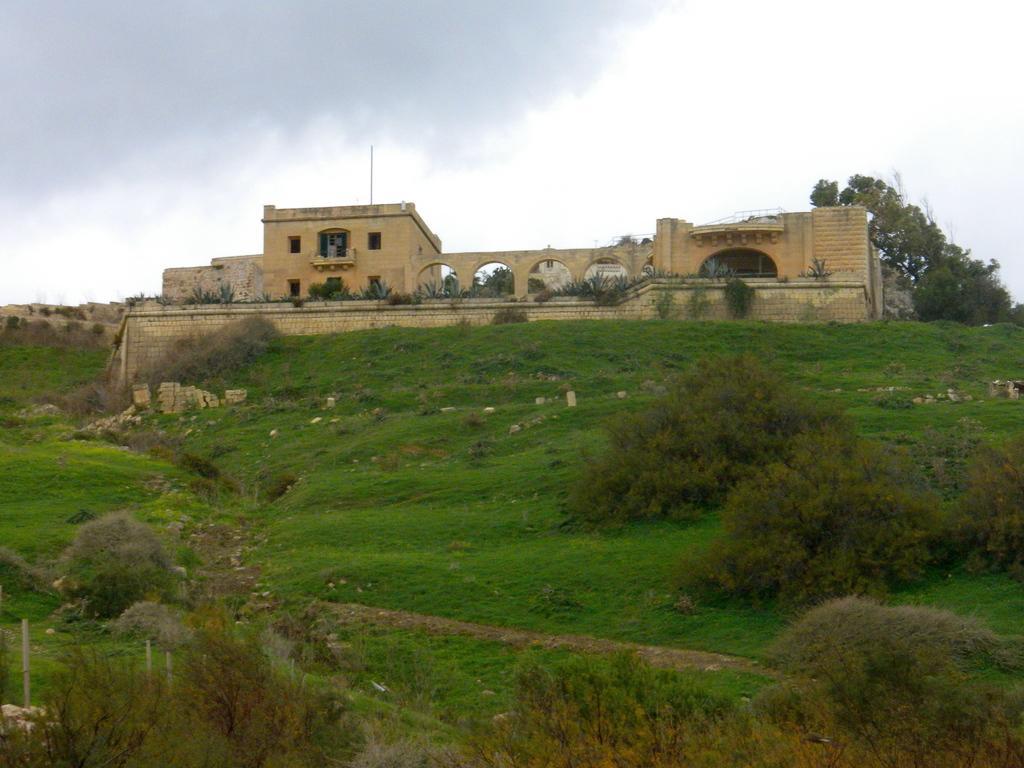How would you summarize this image in a sentence or two? In the picture I can see the grass, plants, trees and buildings. In the background I can see the sky. 